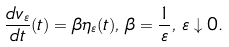<formula> <loc_0><loc_0><loc_500><loc_500>\frac { d v _ { \varepsilon } } { d t } ( t ) = \beta \eta _ { \varepsilon } ( t ) , \, \beta = \frac { 1 } { \varepsilon } , \, \varepsilon \downarrow 0 .</formula> 